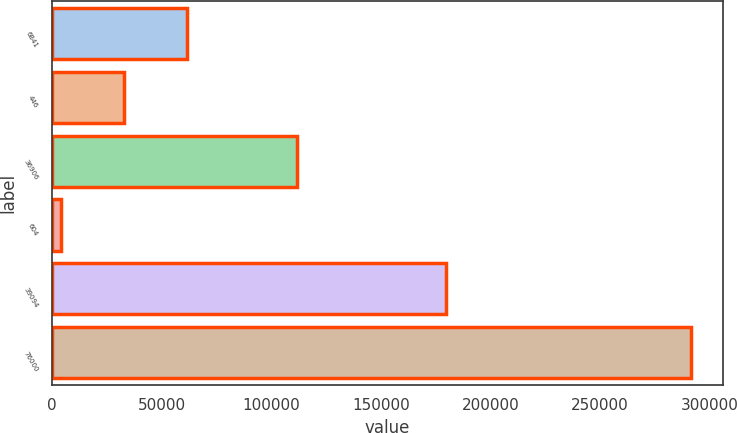<chart> <loc_0><loc_0><loc_500><loc_500><bar_chart><fcel>6841<fcel>446<fcel>36906<fcel>604<fcel>39094<fcel>76000<nl><fcel>61632.8<fcel>32892.4<fcel>111939<fcel>4152<fcel>179617<fcel>291556<nl></chart> 